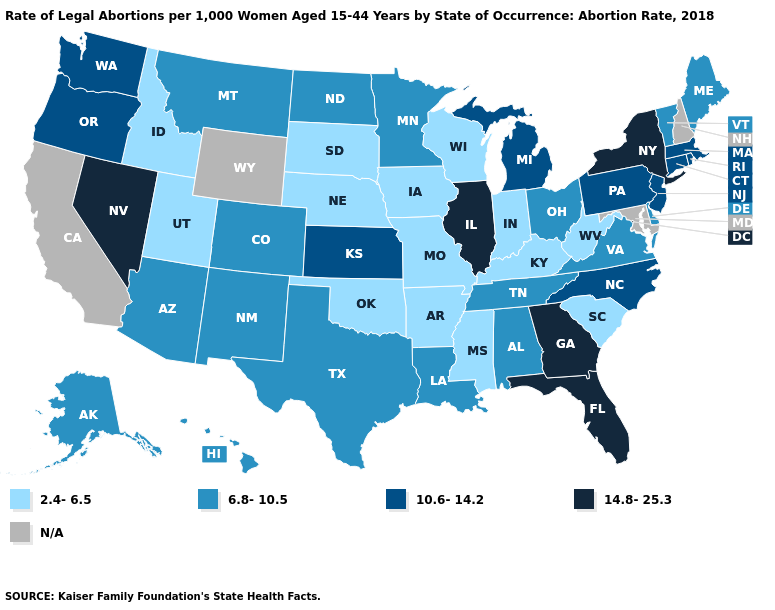How many symbols are there in the legend?
Keep it brief. 5. Name the states that have a value in the range 10.6-14.2?
Give a very brief answer. Connecticut, Kansas, Massachusetts, Michigan, New Jersey, North Carolina, Oregon, Pennsylvania, Rhode Island, Washington. How many symbols are there in the legend?
Short answer required. 5. How many symbols are there in the legend?
Give a very brief answer. 5. What is the value of New Jersey?
Short answer required. 10.6-14.2. Name the states that have a value in the range 10.6-14.2?
Keep it brief. Connecticut, Kansas, Massachusetts, Michigan, New Jersey, North Carolina, Oregon, Pennsylvania, Rhode Island, Washington. How many symbols are there in the legend?
Concise answer only. 5. What is the lowest value in the Northeast?
Concise answer only. 6.8-10.5. Name the states that have a value in the range 2.4-6.5?
Keep it brief. Arkansas, Idaho, Indiana, Iowa, Kentucky, Mississippi, Missouri, Nebraska, Oklahoma, South Carolina, South Dakota, Utah, West Virginia, Wisconsin. Does Kansas have the lowest value in the MidWest?
Keep it brief. No. Which states have the highest value in the USA?
Keep it brief. Florida, Georgia, Illinois, Nevada, New York. What is the value of Colorado?
Short answer required. 6.8-10.5. What is the value of Florida?
Answer briefly. 14.8-25.3. Does Alabama have the highest value in the USA?
Write a very short answer. No. 